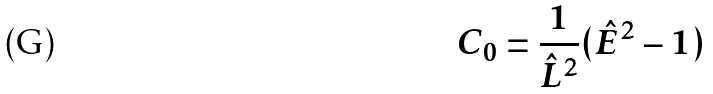<formula> <loc_0><loc_0><loc_500><loc_500>C _ { 0 } = \frac { 1 } { \hat { L } ^ { 2 } } ( \hat { E } ^ { 2 } - 1 )</formula> 